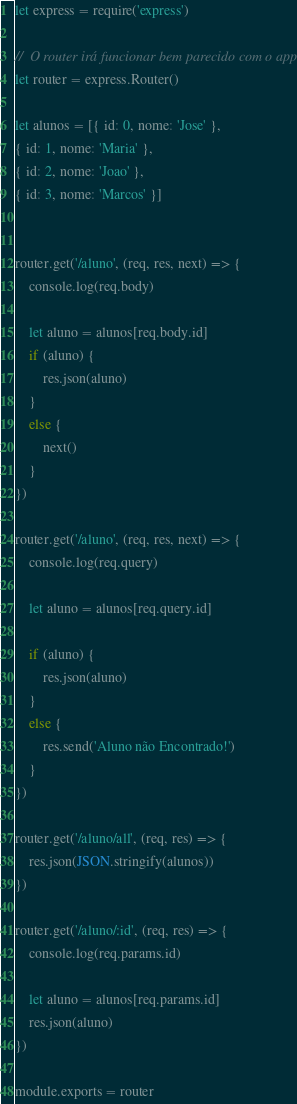<code> <loc_0><loc_0><loc_500><loc_500><_JavaScript_>let express = require('express')

//  O router irá funcionar bem parecido com o app.
let router = express.Router()

let alunos = [{ id: 0, nome: 'Jose' },
{ id: 1, nome: 'Maria' },
{ id: 2, nome: 'Joao' },
{ id: 3, nome: 'Marcos' }]


router.get('/aluno', (req, res, next) => {
    console.log(req.body)

    let aluno = alunos[req.body.id]
    if (aluno) {
        res.json(aluno)
    }
    else {
        next()
    }
})

router.get('/aluno', (req, res, next) => {
    console.log(req.query)

    let aluno = alunos[req.query.id]

    if (aluno) {
        res.json(aluno)
    }
    else {
        res.send('Aluno não Encontrado!')
    }
})

router.get('/aluno/all', (req, res) => {
    res.json(JSON.stringify(alunos))
})

router.get('/aluno/:id', (req, res) => {
    console.log(req.params.id)

    let aluno = alunos[req.params.id]
    res.json(aluno)
})

module.exports = router
</code> 